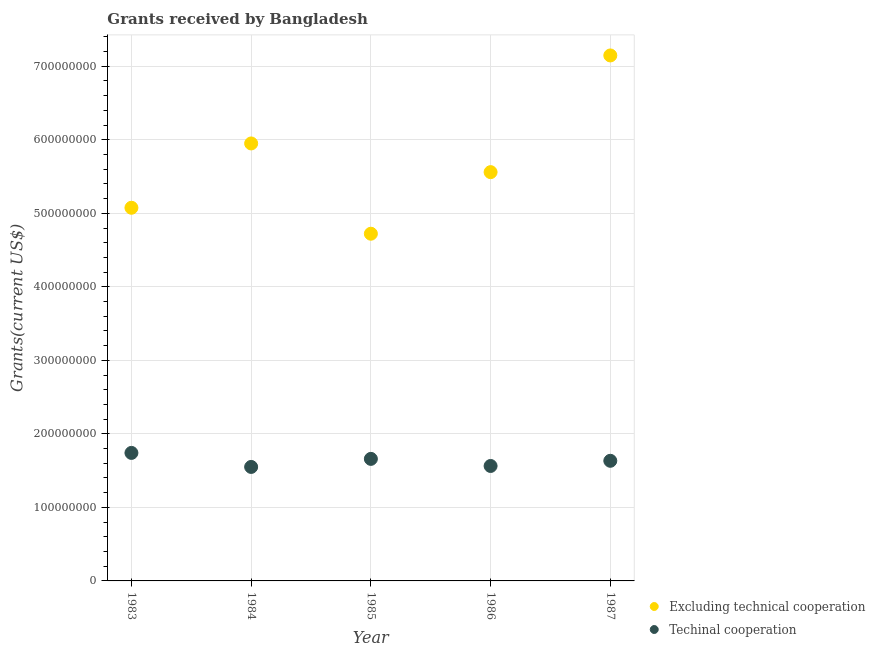Is the number of dotlines equal to the number of legend labels?
Offer a very short reply. Yes. What is the amount of grants received(excluding technical cooperation) in 1983?
Your answer should be very brief. 5.08e+08. Across all years, what is the maximum amount of grants received(excluding technical cooperation)?
Offer a terse response. 7.15e+08. Across all years, what is the minimum amount of grants received(excluding technical cooperation)?
Offer a terse response. 4.72e+08. What is the total amount of grants received(excluding technical cooperation) in the graph?
Your answer should be compact. 2.85e+09. What is the difference between the amount of grants received(excluding technical cooperation) in 1983 and that in 1986?
Ensure brevity in your answer.  -4.85e+07. What is the difference between the amount of grants received(excluding technical cooperation) in 1985 and the amount of grants received(including technical cooperation) in 1984?
Make the answer very short. 3.17e+08. What is the average amount of grants received(excluding technical cooperation) per year?
Keep it short and to the point. 5.69e+08. In the year 1986, what is the difference between the amount of grants received(excluding technical cooperation) and amount of grants received(including technical cooperation)?
Give a very brief answer. 4.00e+08. In how many years, is the amount of grants received(including technical cooperation) greater than 180000000 US$?
Keep it short and to the point. 0. What is the ratio of the amount of grants received(including technical cooperation) in 1986 to that in 1987?
Provide a short and direct response. 0.96. Is the difference between the amount of grants received(excluding technical cooperation) in 1983 and 1987 greater than the difference between the amount of grants received(including technical cooperation) in 1983 and 1987?
Ensure brevity in your answer.  No. What is the difference between the highest and the second highest amount of grants received(including technical cooperation)?
Make the answer very short. 8.12e+06. What is the difference between the highest and the lowest amount of grants received(excluding technical cooperation)?
Offer a terse response. 2.42e+08. In how many years, is the amount of grants received(excluding technical cooperation) greater than the average amount of grants received(excluding technical cooperation) taken over all years?
Your answer should be compact. 2. Where does the legend appear in the graph?
Your answer should be compact. Bottom right. What is the title of the graph?
Give a very brief answer. Grants received by Bangladesh. What is the label or title of the Y-axis?
Ensure brevity in your answer.  Grants(current US$). What is the Grants(current US$) in Excluding technical cooperation in 1983?
Offer a terse response. 5.08e+08. What is the Grants(current US$) of Techinal cooperation in 1983?
Offer a very short reply. 1.74e+08. What is the Grants(current US$) of Excluding technical cooperation in 1984?
Offer a very short reply. 5.95e+08. What is the Grants(current US$) in Techinal cooperation in 1984?
Your answer should be compact. 1.55e+08. What is the Grants(current US$) of Excluding technical cooperation in 1985?
Provide a succinct answer. 4.72e+08. What is the Grants(current US$) in Techinal cooperation in 1985?
Keep it short and to the point. 1.66e+08. What is the Grants(current US$) in Excluding technical cooperation in 1986?
Your response must be concise. 5.56e+08. What is the Grants(current US$) of Techinal cooperation in 1986?
Make the answer very short. 1.56e+08. What is the Grants(current US$) in Excluding technical cooperation in 1987?
Keep it short and to the point. 7.15e+08. What is the Grants(current US$) in Techinal cooperation in 1987?
Your answer should be compact. 1.63e+08. Across all years, what is the maximum Grants(current US$) in Excluding technical cooperation?
Make the answer very short. 7.15e+08. Across all years, what is the maximum Grants(current US$) of Techinal cooperation?
Your answer should be very brief. 1.74e+08. Across all years, what is the minimum Grants(current US$) in Excluding technical cooperation?
Keep it short and to the point. 4.72e+08. Across all years, what is the minimum Grants(current US$) in Techinal cooperation?
Give a very brief answer. 1.55e+08. What is the total Grants(current US$) in Excluding technical cooperation in the graph?
Offer a terse response. 2.85e+09. What is the total Grants(current US$) in Techinal cooperation in the graph?
Your answer should be compact. 8.15e+08. What is the difference between the Grants(current US$) of Excluding technical cooperation in 1983 and that in 1984?
Your answer should be very brief. -8.75e+07. What is the difference between the Grants(current US$) of Techinal cooperation in 1983 and that in 1984?
Provide a succinct answer. 1.91e+07. What is the difference between the Grants(current US$) of Excluding technical cooperation in 1983 and that in 1985?
Provide a succinct answer. 3.53e+07. What is the difference between the Grants(current US$) in Techinal cooperation in 1983 and that in 1985?
Keep it short and to the point. 8.12e+06. What is the difference between the Grants(current US$) of Excluding technical cooperation in 1983 and that in 1986?
Offer a very short reply. -4.85e+07. What is the difference between the Grants(current US$) in Techinal cooperation in 1983 and that in 1986?
Provide a succinct answer. 1.78e+07. What is the difference between the Grants(current US$) in Excluding technical cooperation in 1983 and that in 1987?
Ensure brevity in your answer.  -2.07e+08. What is the difference between the Grants(current US$) in Techinal cooperation in 1983 and that in 1987?
Ensure brevity in your answer.  1.07e+07. What is the difference between the Grants(current US$) in Excluding technical cooperation in 1984 and that in 1985?
Provide a short and direct response. 1.23e+08. What is the difference between the Grants(current US$) in Techinal cooperation in 1984 and that in 1985?
Provide a succinct answer. -1.10e+07. What is the difference between the Grants(current US$) of Excluding technical cooperation in 1984 and that in 1986?
Offer a terse response. 3.90e+07. What is the difference between the Grants(current US$) in Techinal cooperation in 1984 and that in 1986?
Offer a terse response. -1.30e+06. What is the difference between the Grants(current US$) in Excluding technical cooperation in 1984 and that in 1987?
Offer a very short reply. -1.20e+08. What is the difference between the Grants(current US$) in Techinal cooperation in 1984 and that in 1987?
Ensure brevity in your answer.  -8.34e+06. What is the difference between the Grants(current US$) in Excluding technical cooperation in 1985 and that in 1986?
Offer a terse response. -8.38e+07. What is the difference between the Grants(current US$) of Techinal cooperation in 1985 and that in 1986?
Offer a terse response. 9.65e+06. What is the difference between the Grants(current US$) of Excluding technical cooperation in 1985 and that in 1987?
Ensure brevity in your answer.  -2.42e+08. What is the difference between the Grants(current US$) of Techinal cooperation in 1985 and that in 1987?
Make the answer very short. 2.61e+06. What is the difference between the Grants(current US$) of Excluding technical cooperation in 1986 and that in 1987?
Offer a terse response. -1.59e+08. What is the difference between the Grants(current US$) in Techinal cooperation in 1986 and that in 1987?
Your response must be concise. -7.04e+06. What is the difference between the Grants(current US$) of Excluding technical cooperation in 1983 and the Grants(current US$) of Techinal cooperation in 1984?
Provide a succinct answer. 3.53e+08. What is the difference between the Grants(current US$) of Excluding technical cooperation in 1983 and the Grants(current US$) of Techinal cooperation in 1985?
Give a very brief answer. 3.42e+08. What is the difference between the Grants(current US$) of Excluding technical cooperation in 1983 and the Grants(current US$) of Techinal cooperation in 1986?
Offer a very short reply. 3.51e+08. What is the difference between the Grants(current US$) of Excluding technical cooperation in 1983 and the Grants(current US$) of Techinal cooperation in 1987?
Ensure brevity in your answer.  3.44e+08. What is the difference between the Grants(current US$) in Excluding technical cooperation in 1984 and the Grants(current US$) in Techinal cooperation in 1985?
Offer a very short reply. 4.29e+08. What is the difference between the Grants(current US$) in Excluding technical cooperation in 1984 and the Grants(current US$) in Techinal cooperation in 1986?
Give a very brief answer. 4.39e+08. What is the difference between the Grants(current US$) in Excluding technical cooperation in 1984 and the Grants(current US$) in Techinal cooperation in 1987?
Offer a very short reply. 4.32e+08. What is the difference between the Grants(current US$) in Excluding technical cooperation in 1985 and the Grants(current US$) in Techinal cooperation in 1986?
Your answer should be very brief. 3.16e+08. What is the difference between the Grants(current US$) of Excluding technical cooperation in 1985 and the Grants(current US$) of Techinal cooperation in 1987?
Offer a terse response. 3.09e+08. What is the difference between the Grants(current US$) in Excluding technical cooperation in 1986 and the Grants(current US$) in Techinal cooperation in 1987?
Provide a succinct answer. 3.93e+08. What is the average Grants(current US$) of Excluding technical cooperation per year?
Provide a short and direct response. 5.69e+08. What is the average Grants(current US$) of Techinal cooperation per year?
Ensure brevity in your answer.  1.63e+08. In the year 1983, what is the difference between the Grants(current US$) in Excluding technical cooperation and Grants(current US$) in Techinal cooperation?
Your response must be concise. 3.33e+08. In the year 1984, what is the difference between the Grants(current US$) of Excluding technical cooperation and Grants(current US$) of Techinal cooperation?
Offer a terse response. 4.40e+08. In the year 1985, what is the difference between the Grants(current US$) of Excluding technical cooperation and Grants(current US$) of Techinal cooperation?
Keep it short and to the point. 3.06e+08. In the year 1986, what is the difference between the Grants(current US$) of Excluding technical cooperation and Grants(current US$) of Techinal cooperation?
Ensure brevity in your answer.  4.00e+08. In the year 1987, what is the difference between the Grants(current US$) of Excluding technical cooperation and Grants(current US$) of Techinal cooperation?
Your answer should be very brief. 5.51e+08. What is the ratio of the Grants(current US$) of Excluding technical cooperation in 1983 to that in 1984?
Provide a succinct answer. 0.85. What is the ratio of the Grants(current US$) of Techinal cooperation in 1983 to that in 1984?
Offer a very short reply. 1.12. What is the ratio of the Grants(current US$) of Excluding technical cooperation in 1983 to that in 1985?
Your answer should be compact. 1.07. What is the ratio of the Grants(current US$) in Techinal cooperation in 1983 to that in 1985?
Your answer should be very brief. 1.05. What is the ratio of the Grants(current US$) in Excluding technical cooperation in 1983 to that in 1986?
Provide a succinct answer. 0.91. What is the ratio of the Grants(current US$) of Techinal cooperation in 1983 to that in 1986?
Offer a terse response. 1.11. What is the ratio of the Grants(current US$) in Excluding technical cooperation in 1983 to that in 1987?
Provide a succinct answer. 0.71. What is the ratio of the Grants(current US$) of Techinal cooperation in 1983 to that in 1987?
Provide a succinct answer. 1.07. What is the ratio of the Grants(current US$) in Excluding technical cooperation in 1984 to that in 1985?
Your response must be concise. 1.26. What is the ratio of the Grants(current US$) of Techinal cooperation in 1984 to that in 1985?
Provide a short and direct response. 0.93. What is the ratio of the Grants(current US$) in Excluding technical cooperation in 1984 to that in 1986?
Your response must be concise. 1.07. What is the ratio of the Grants(current US$) in Excluding technical cooperation in 1984 to that in 1987?
Provide a short and direct response. 0.83. What is the ratio of the Grants(current US$) in Techinal cooperation in 1984 to that in 1987?
Offer a terse response. 0.95. What is the ratio of the Grants(current US$) of Excluding technical cooperation in 1985 to that in 1986?
Provide a succinct answer. 0.85. What is the ratio of the Grants(current US$) in Techinal cooperation in 1985 to that in 1986?
Provide a short and direct response. 1.06. What is the ratio of the Grants(current US$) of Excluding technical cooperation in 1985 to that in 1987?
Keep it short and to the point. 0.66. What is the ratio of the Grants(current US$) in Techinal cooperation in 1985 to that in 1987?
Your answer should be very brief. 1.02. What is the ratio of the Grants(current US$) of Excluding technical cooperation in 1986 to that in 1987?
Your response must be concise. 0.78. What is the ratio of the Grants(current US$) of Techinal cooperation in 1986 to that in 1987?
Your answer should be very brief. 0.96. What is the difference between the highest and the second highest Grants(current US$) in Excluding technical cooperation?
Offer a very short reply. 1.20e+08. What is the difference between the highest and the second highest Grants(current US$) of Techinal cooperation?
Offer a very short reply. 8.12e+06. What is the difference between the highest and the lowest Grants(current US$) in Excluding technical cooperation?
Offer a terse response. 2.42e+08. What is the difference between the highest and the lowest Grants(current US$) in Techinal cooperation?
Offer a very short reply. 1.91e+07. 